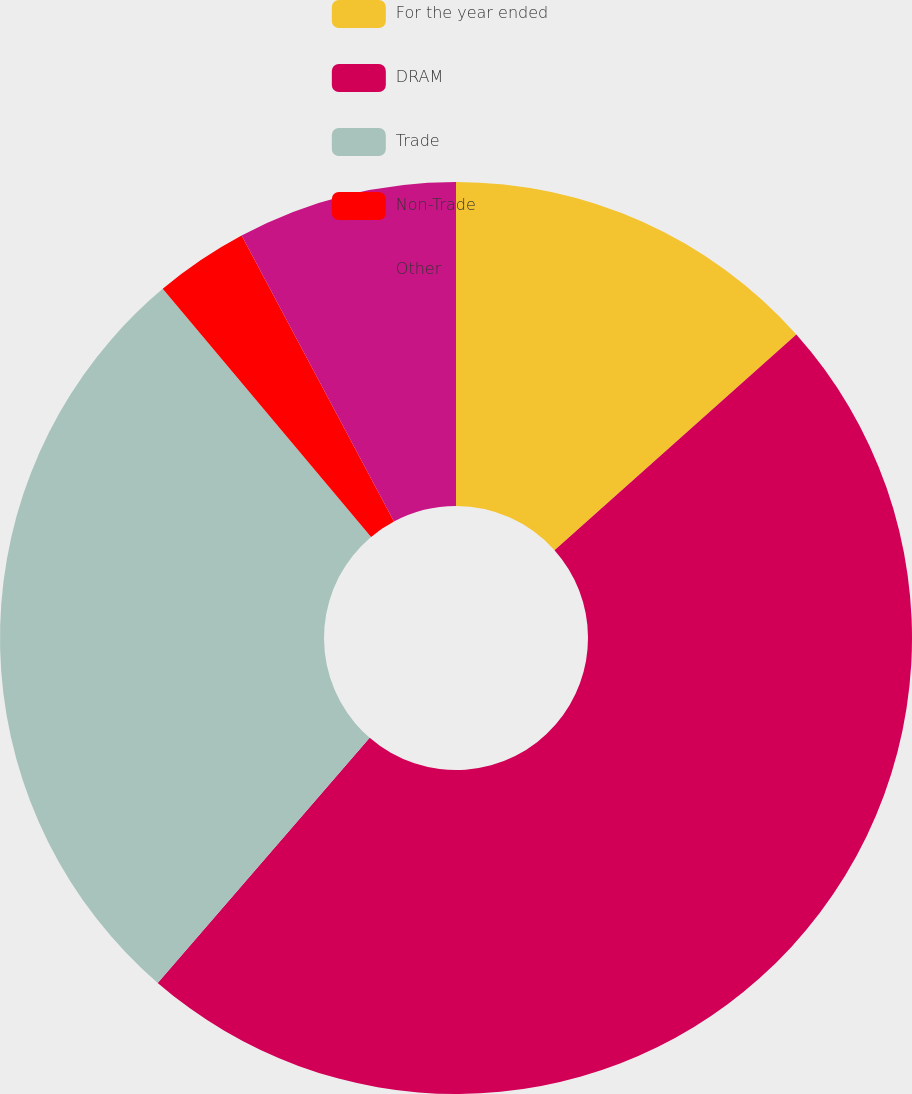Convert chart. <chart><loc_0><loc_0><loc_500><loc_500><pie_chart><fcel>For the year ended<fcel>DRAM<fcel>Trade<fcel>Non-Trade<fcel>Other<nl><fcel>13.41%<fcel>47.94%<fcel>27.53%<fcel>3.33%<fcel>7.79%<nl></chart> 